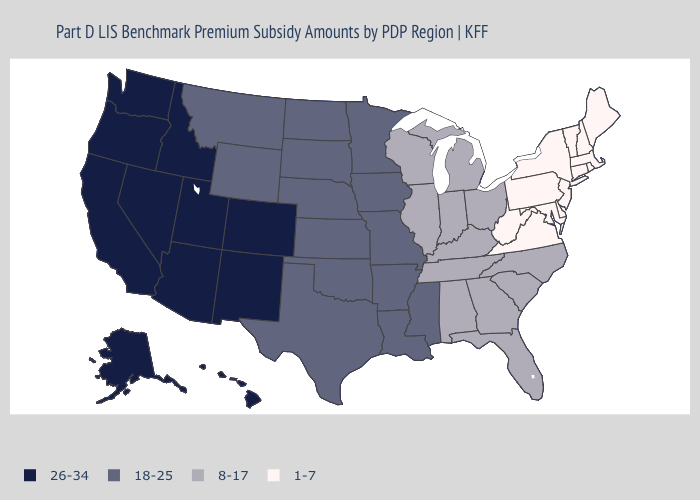Does Illinois have the same value as Utah?
Keep it brief. No. What is the lowest value in the MidWest?
Quick response, please. 8-17. Does Maryland have the lowest value in the USA?
Quick response, please. Yes. What is the value of Texas?
Concise answer only. 18-25. Does the map have missing data?
Concise answer only. No. What is the value of Nebraska?
Be succinct. 18-25. Name the states that have a value in the range 26-34?
Short answer required. Alaska, Arizona, California, Colorado, Hawaii, Idaho, Nevada, New Mexico, Oregon, Utah, Washington. How many symbols are there in the legend?
Give a very brief answer. 4. Name the states that have a value in the range 26-34?
Give a very brief answer. Alaska, Arizona, California, Colorado, Hawaii, Idaho, Nevada, New Mexico, Oregon, Utah, Washington. Does Delaware have the lowest value in the USA?
Quick response, please. Yes. Among the states that border North Carolina , does Virginia have the highest value?
Give a very brief answer. No. Does the map have missing data?
Write a very short answer. No. Name the states that have a value in the range 1-7?
Give a very brief answer. Connecticut, Delaware, Maine, Maryland, Massachusetts, New Hampshire, New Jersey, New York, Pennsylvania, Rhode Island, Vermont, Virginia, West Virginia. What is the lowest value in the USA?
Keep it brief. 1-7. What is the lowest value in states that border West Virginia?
Be succinct. 1-7. 